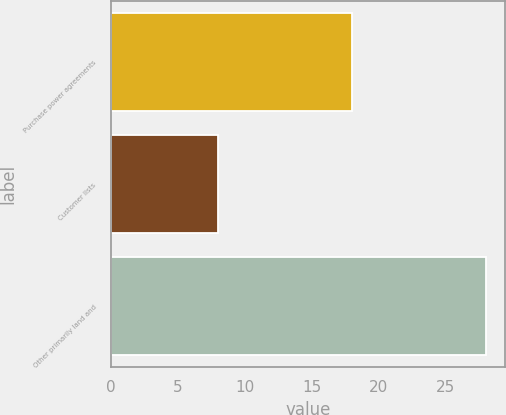Convert chart. <chart><loc_0><loc_0><loc_500><loc_500><bar_chart><fcel>Purchase power agreements<fcel>Customer lists<fcel>Other primarily land and<nl><fcel>18<fcel>8<fcel>28<nl></chart> 